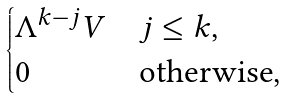<formula> <loc_0><loc_0><loc_500><loc_500>\begin{cases} \Lambda ^ { k - j } V & j \leq k , \\ 0 & \text {otherwise,} \end{cases}</formula> 